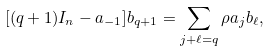Convert formula to latex. <formula><loc_0><loc_0><loc_500><loc_500>[ ( q + 1 ) I _ { n } - a _ { - 1 } ] b _ { q + 1 } = \sum _ { j + \ell = q } { \rho } a _ { j } b _ { \ell } ,</formula> 